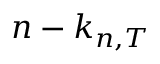<formula> <loc_0><loc_0><loc_500><loc_500>n - k _ { n , T }</formula> 